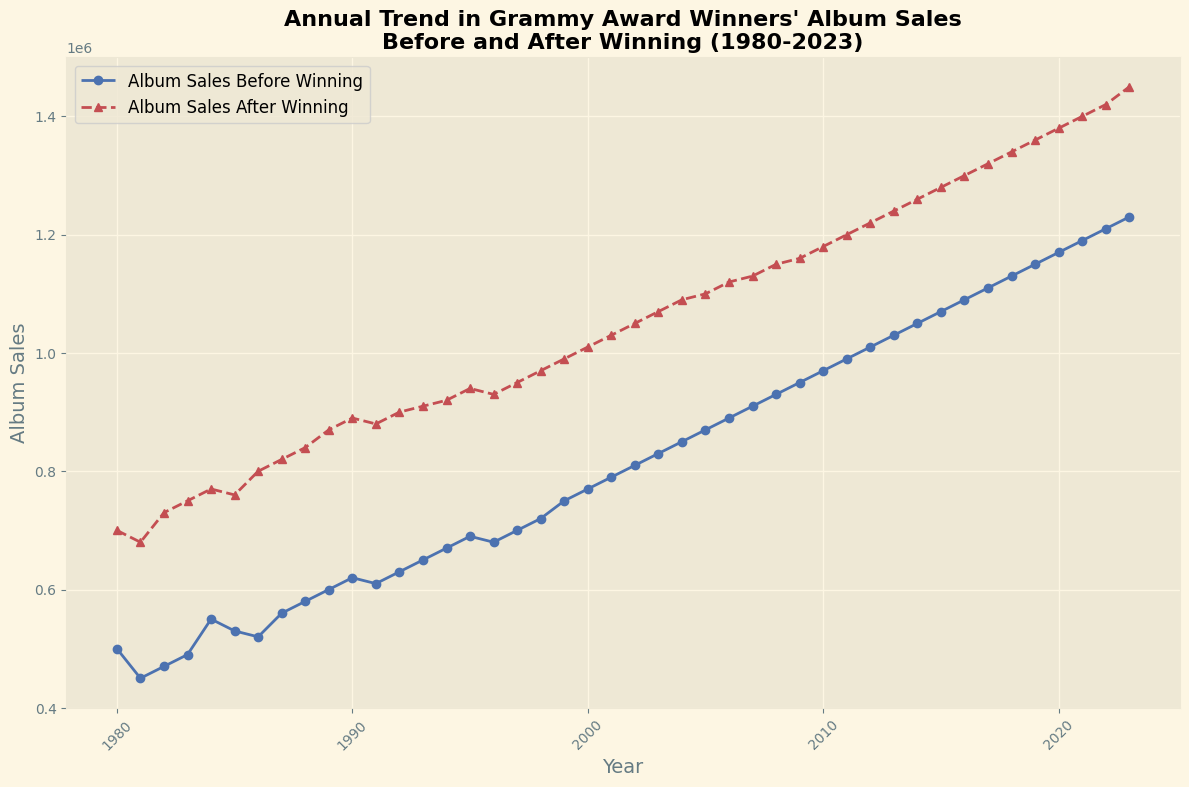Which year shows the greatest increase in album sales after winning compared to before winning? To find the year with the greatest increase, look at the difference between "Album Sales After Winning" and "Album Sales Before Winning" for each year and identify the maximum value.
Answer: 2023 Between which two consecutive years is the largest drop in album sales before winning observed? To find this, calculate the differences between "Album Sales Before Winning" for each consecutive year and identify the largest negative value. Note that in this dataset, there is no significant drop.
Answer: None (no significant drops) Which year first shows album sales before winning reaching over 1 million? Identify the first year where "Album Sales Before Winning" exceeds 1,000,000. It shows that in 2011 the sales before winning are 990,000, and in 2012 it is 1,010,000.
Answer: 2012 Are album sales after winning consistently higher than before winning every year? Compare "Album Sales After Winning" to "Album Sales Before Winning" for every year. Since each year, the sales after winning are higher, the answer is yes.
Answer: Yes From 1980 to 2023, what's the average increase in album sales after winning a Grammy? Calculate the difference for each year between "Album Sales After Winning" and "Album Sales Before Winning," sum these differences, then divide by the number of years (2023-1980+1). Add all the differences, which equals 8,700,000, and divide by the number of years, which is 44.
Answer: 197727 Between which two years did the album sales before winning first exhibit the smallest annual increase? Determine the smallest positive difference between consecutive years for "Album Sales Before Winning". From 1980 to 1981, the change is -50,000, but note that the smallest increase occurred from 1995 to 1996 with a change of -10,000.
Answer: 1995 to 1996 How do the trends in album sales before and after winning differ between the 1980s and the 2000s? Compare the general slope or direction of the curves in these two decades. The 1980s show a modest increase, while the 2000s exhibit a steeper increase for both "Album Sales Before Winning" and "Album Sales After Winning".
Answer: Steeper increase in 2000s What is the median album sales after winning in the 1990s? List all "Album Sales After Winning" for the years 1990-1999, then find the median value of these data points. Values: 890,000, 880,000, 900,000, 910,000, 920,000, 940,000, 930,000, 950,000, 970,000, 990,000. Middle values (when sorted): 910,000 and 920,000, so (910,000 + 920,000)/2.
Answer: 915000 In which decade did album sales after winning first exceed 1 million? Identify the first year "Album Sales After Winning" surpasses 1,000,000 and determine the decade it falls into. Since the year is 2000 and the sales reach 1,010,000.
Answer: 2000s What is the increase rate trend for album sales before winning from 1980 to 2023? Examine how "Album Sales Before Winning" changes over time and characterize the general trend. The trend shows a consistent increasing pattern with a few minor drops but no significant reversal.
Answer: Consistent increase 